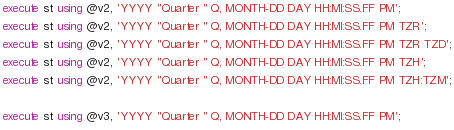<code> <loc_0><loc_0><loc_500><loc_500><_SQL_>
execute st using @v2, 'YYYY "Quarter " Q, MONTH-DD DAY HH:MI:SS.FF PM';
execute st using @v2, 'YYYY "Quarter " Q, MONTH-DD DAY HH:MI:SS.FF PM TZR';
execute st using @v2, 'YYYY "Quarter " Q, MONTH-DD DAY HH:MI:SS.FF PM TZR TZD';
execute st using @v2, 'YYYY "Quarter " Q, MONTH-DD DAY HH:MI:SS.FF PM TZH';
execute st using @v2, 'YYYY "Quarter " Q, MONTH-DD DAY HH:MI:SS.FF PM TZH:TZM';

execute st using @v3, 'YYYY "Quarter " Q, MONTH-DD DAY HH:MI:SS.FF PM';</code> 